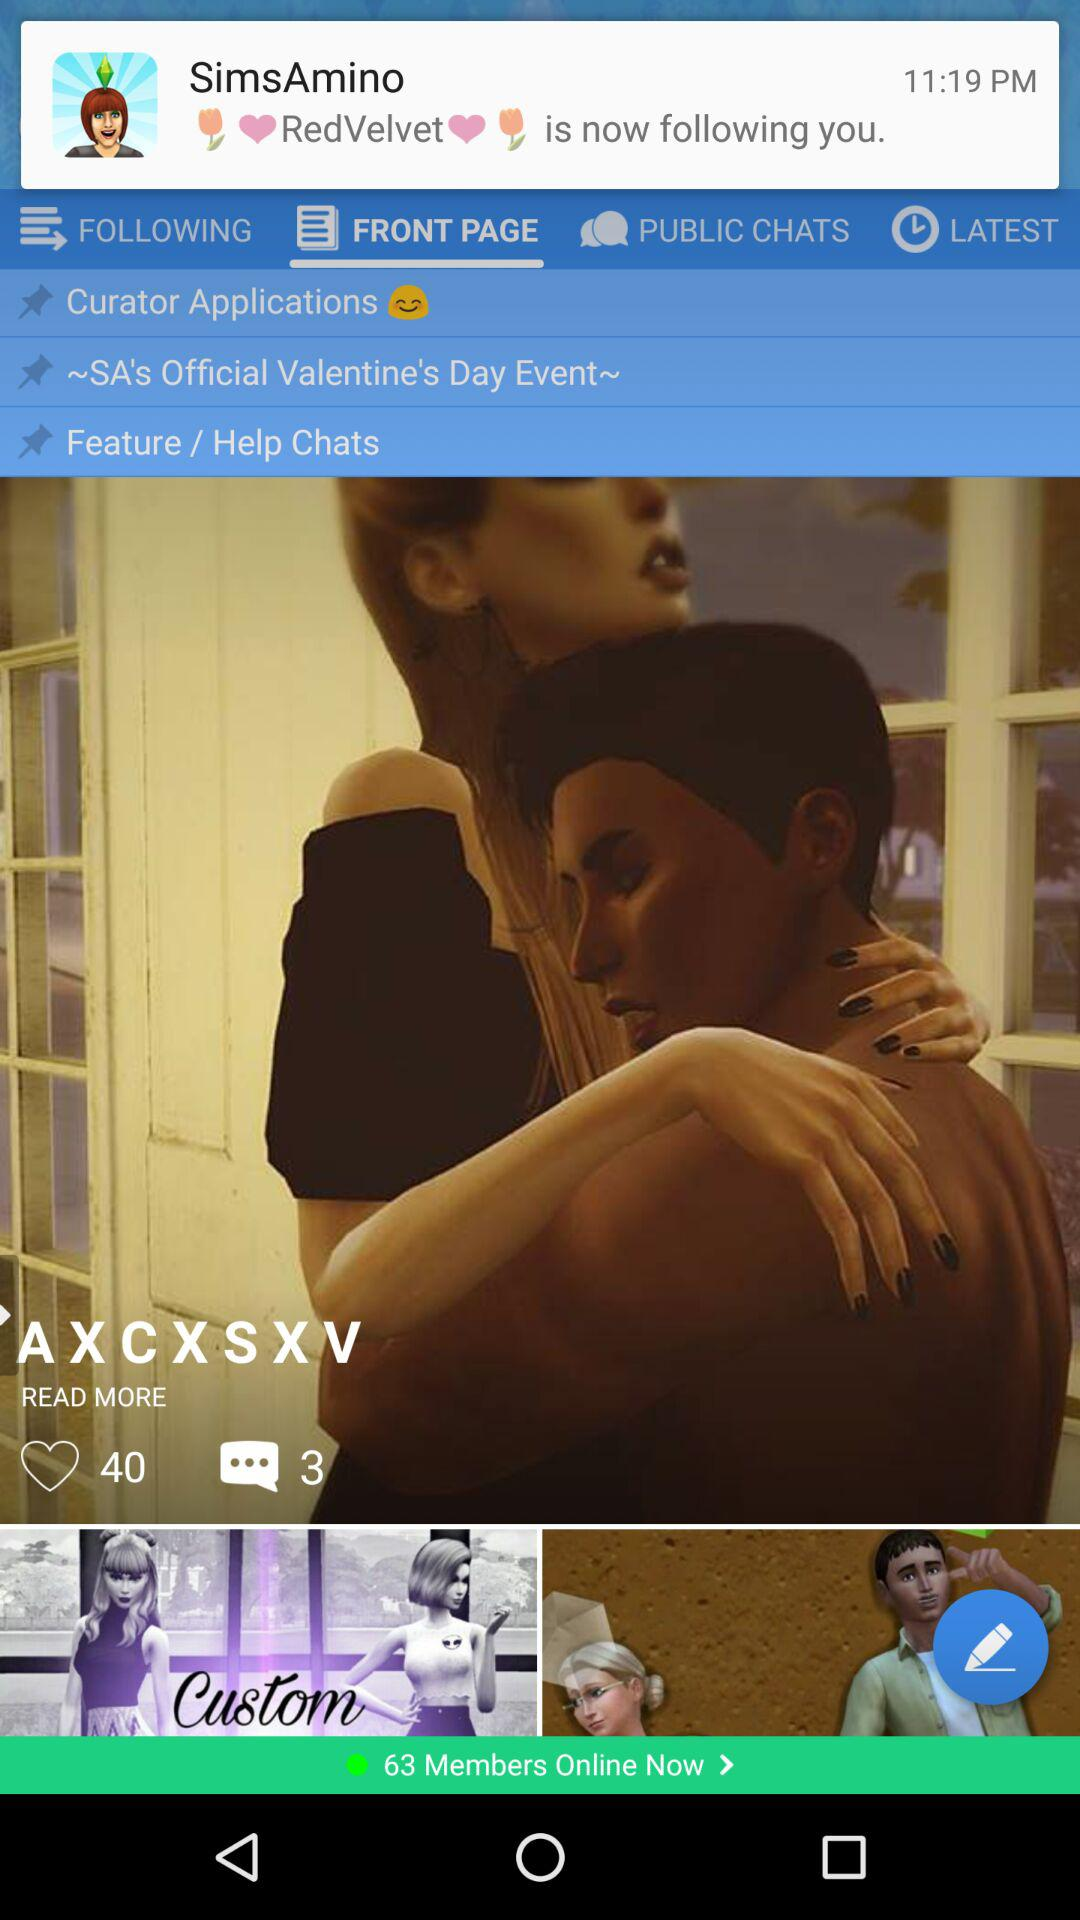How many comments are there on the post? There are 3 comments. 